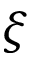Convert formula to latex. <formula><loc_0><loc_0><loc_500><loc_500>\xi</formula> 